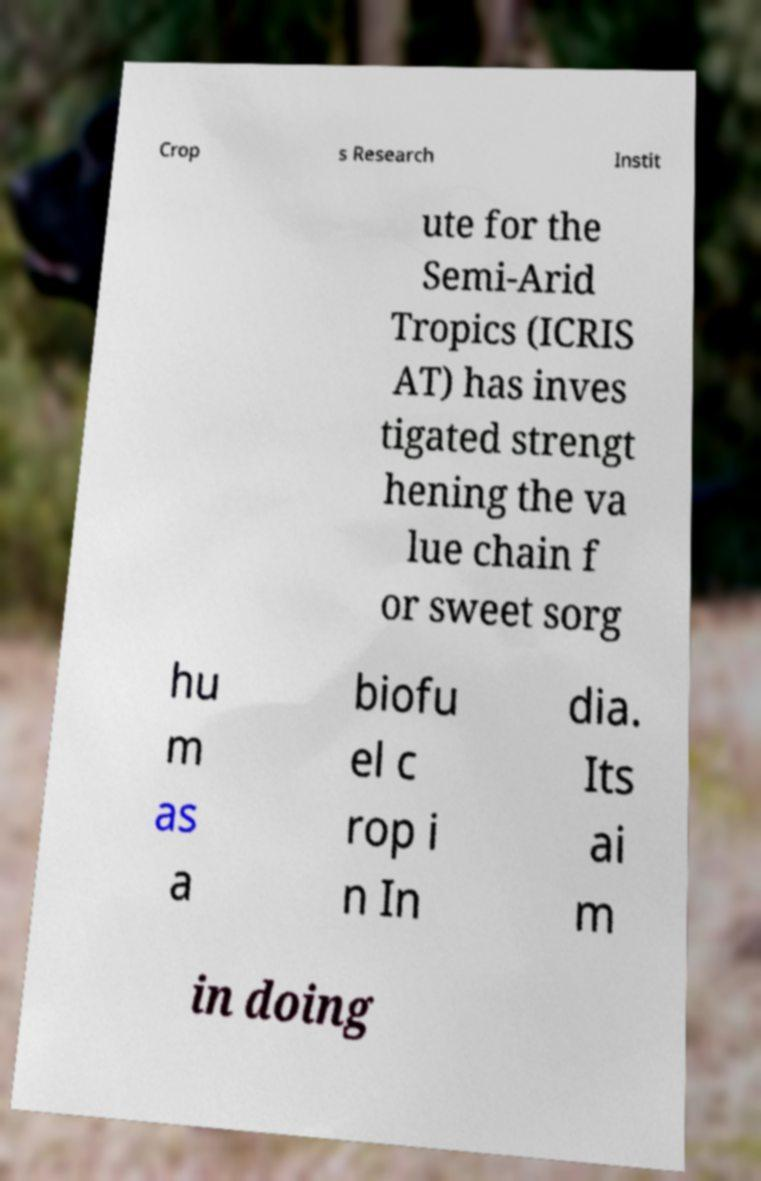For documentation purposes, I need the text within this image transcribed. Could you provide that? Crop s Research Instit ute for the Semi-Arid Tropics (ICRIS AT) has inves tigated strengt hening the va lue chain f or sweet sorg hu m as a biofu el c rop i n In dia. Its ai m in doing 